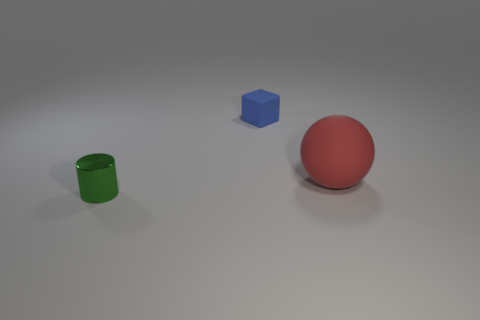The blue thing that is the same material as the red thing is what shape?
Give a very brief answer. Cube. What material is the small object in front of the rubber thing that is in front of the small thing that is to the right of the tiny metal object?
Make the answer very short. Metal. What number of things are tiny things to the left of the blue matte thing or big red objects?
Ensure brevity in your answer.  2. How many other objects are there of the same shape as the big red rubber thing?
Give a very brief answer. 0. Are there more red rubber spheres in front of the shiny object than green cylinders?
Your answer should be very brief. No. Is there anything else that is made of the same material as the red ball?
Give a very brief answer. Yes. What is the shape of the small blue object?
Make the answer very short. Cube. What shape is the thing that is the same size as the metal cylinder?
Keep it short and to the point. Cube. Is there any other thing that has the same color as the sphere?
Your response must be concise. No. There is a blue object that is made of the same material as the large sphere; what is its size?
Give a very brief answer. Small. 